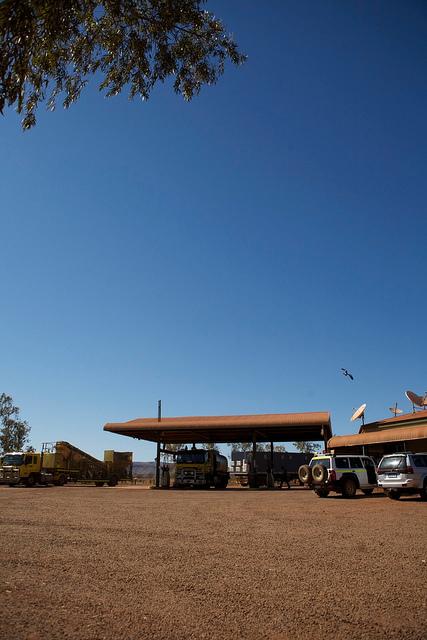Is there water here?
Concise answer only. No. What color is the grass?
Give a very brief answer. Brown. Why are the cars there?
Be succinct. Because people needed to go there. Is there writing visible in this image?
Keep it brief. No. Can you see any trees?
Concise answer only. Yes. Is it cloudy?
Be succinct. No. Is this a fixed wing aircraft?
Write a very short answer. No. Is this a stable?
Give a very brief answer. No. Can you see a blue car?
Answer briefly. No. Where is it?
Give a very brief answer. Gas station. Is there a log cabin in this picture?
Be succinct. No. How many white cars are in this picture?
Be succinct. 2. Is this at the airport?
Concise answer only. No. Is this a quiet and serene location?
Keep it brief. Yes. Is this at an airport?
Write a very short answer. No. Is it a nice day?
Concise answer only. Yes. Are there clouds in the sky?
Be succinct. No. Is this at a college?
Short answer required. No. How many people are in the photo?
Give a very brief answer. 0. Is this a black and white photo?
Concise answer only. No. What does the sky look like?
Give a very brief answer. Clear. What type of vehicle is this?
Short answer required. Truck. Where was this picture taken?
Short answer required. Outdoors. Will it rain soon?
Quick response, please. No. Are there any shadows?
Concise answer only. Yes. Is this a wooden floor?
Keep it brief. No. What color is the photo?
Concise answer only. Blue, brown, green, white. Can thing fly?
Be succinct. No. How many bears are there?
Short answer required. 0. 